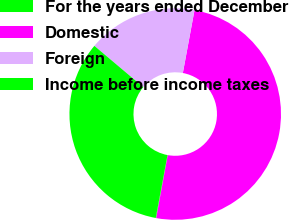Convert chart to OTSL. <chart><loc_0><loc_0><loc_500><loc_500><pie_chart><fcel>For the years ended December<fcel>Domestic<fcel>Foreign<fcel>Income before income taxes<nl><fcel>0.07%<fcel>49.96%<fcel>16.77%<fcel>33.19%<nl></chart> 